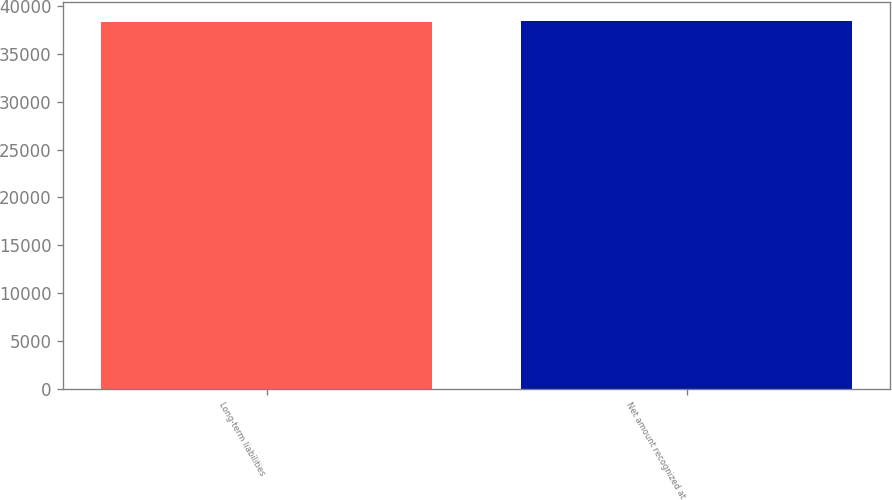<chart> <loc_0><loc_0><loc_500><loc_500><bar_chart><fcel>Long-term liabilities<fcel>Net amount recognized at<nl><fcel>38335<fcel>38475<nl></chart> 